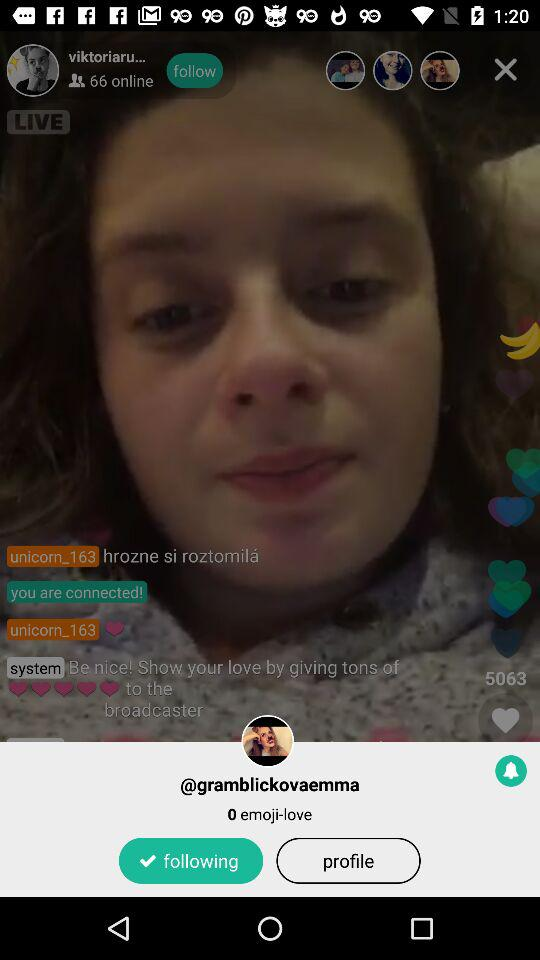How many hearts have been given to the broadcaster?
Answer the question using a single word or phrase. 5063 